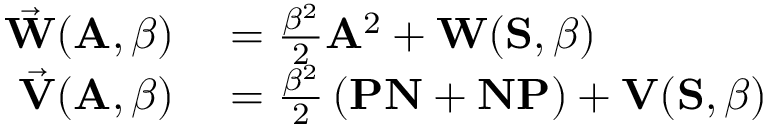<formula> <loc_0><loc_0><loc_500><loc_500>\begin{array} { r l } { \vec { W } ( A , \beta ) } & = \frac { \beta ^ { 2 } } { 2 } A ^ { 2 } + W ( S , \beta ) } \\ { \vec { V } ( A , \beta ) } & = \frac { \beta ^ { 2 } } { 2 } \left ( P N + N P \right ) + V ( S , \beta ) } \end{array}</formula> 